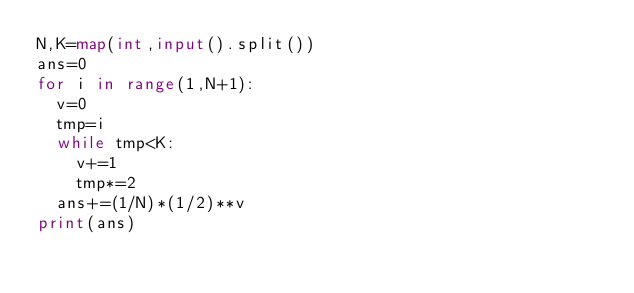<code> <loc_0><loc_0><loc_500><loc_500><_Python_>N,K=map(int,input().split())
ans=0
for i in range(1,N+1):
  v=0
  tmp=i
  while tmp<K:
    v+=1
    tmp*=2
  ans+=(1/N)*(1/2)**v
print(ans)</code> 